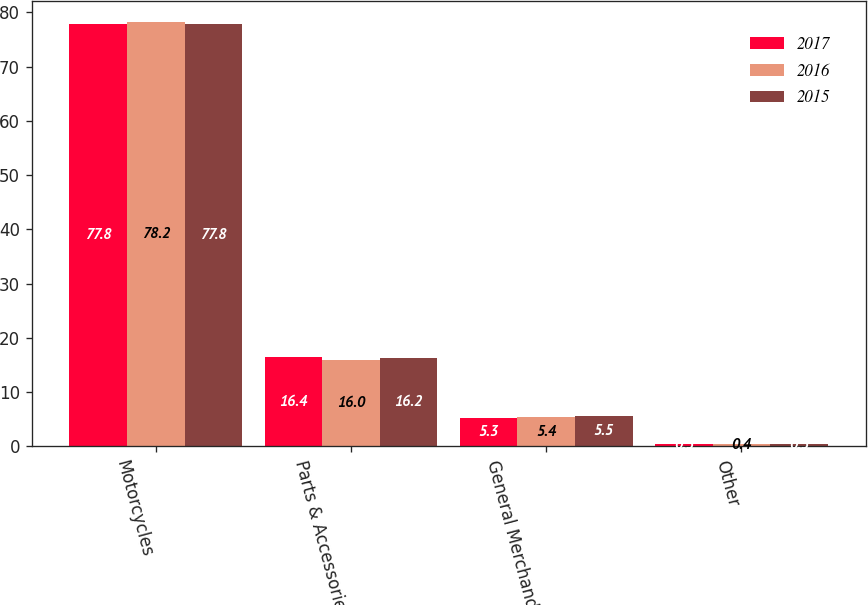Convert chart. <chart><loc_0><loc_0><loc_500><loc_500><stacked_bar_chart><ecel><fcel>Motorcycles<fcel>Parts & Accessories<fcel>General Merchandise<fcel>Other<nl><fcel>2017<fcel>77.8<fcel>16.4<fcel>5.3<fcel>0.5<nl><fcel>2016<fcel>78.2<fcel>16<fcel>5.4<fcel>0.4<nl><fcel>2015<fcel>77.8<fcel>16.2<fcel>5.5<fcel>0.5<nl></chart> 